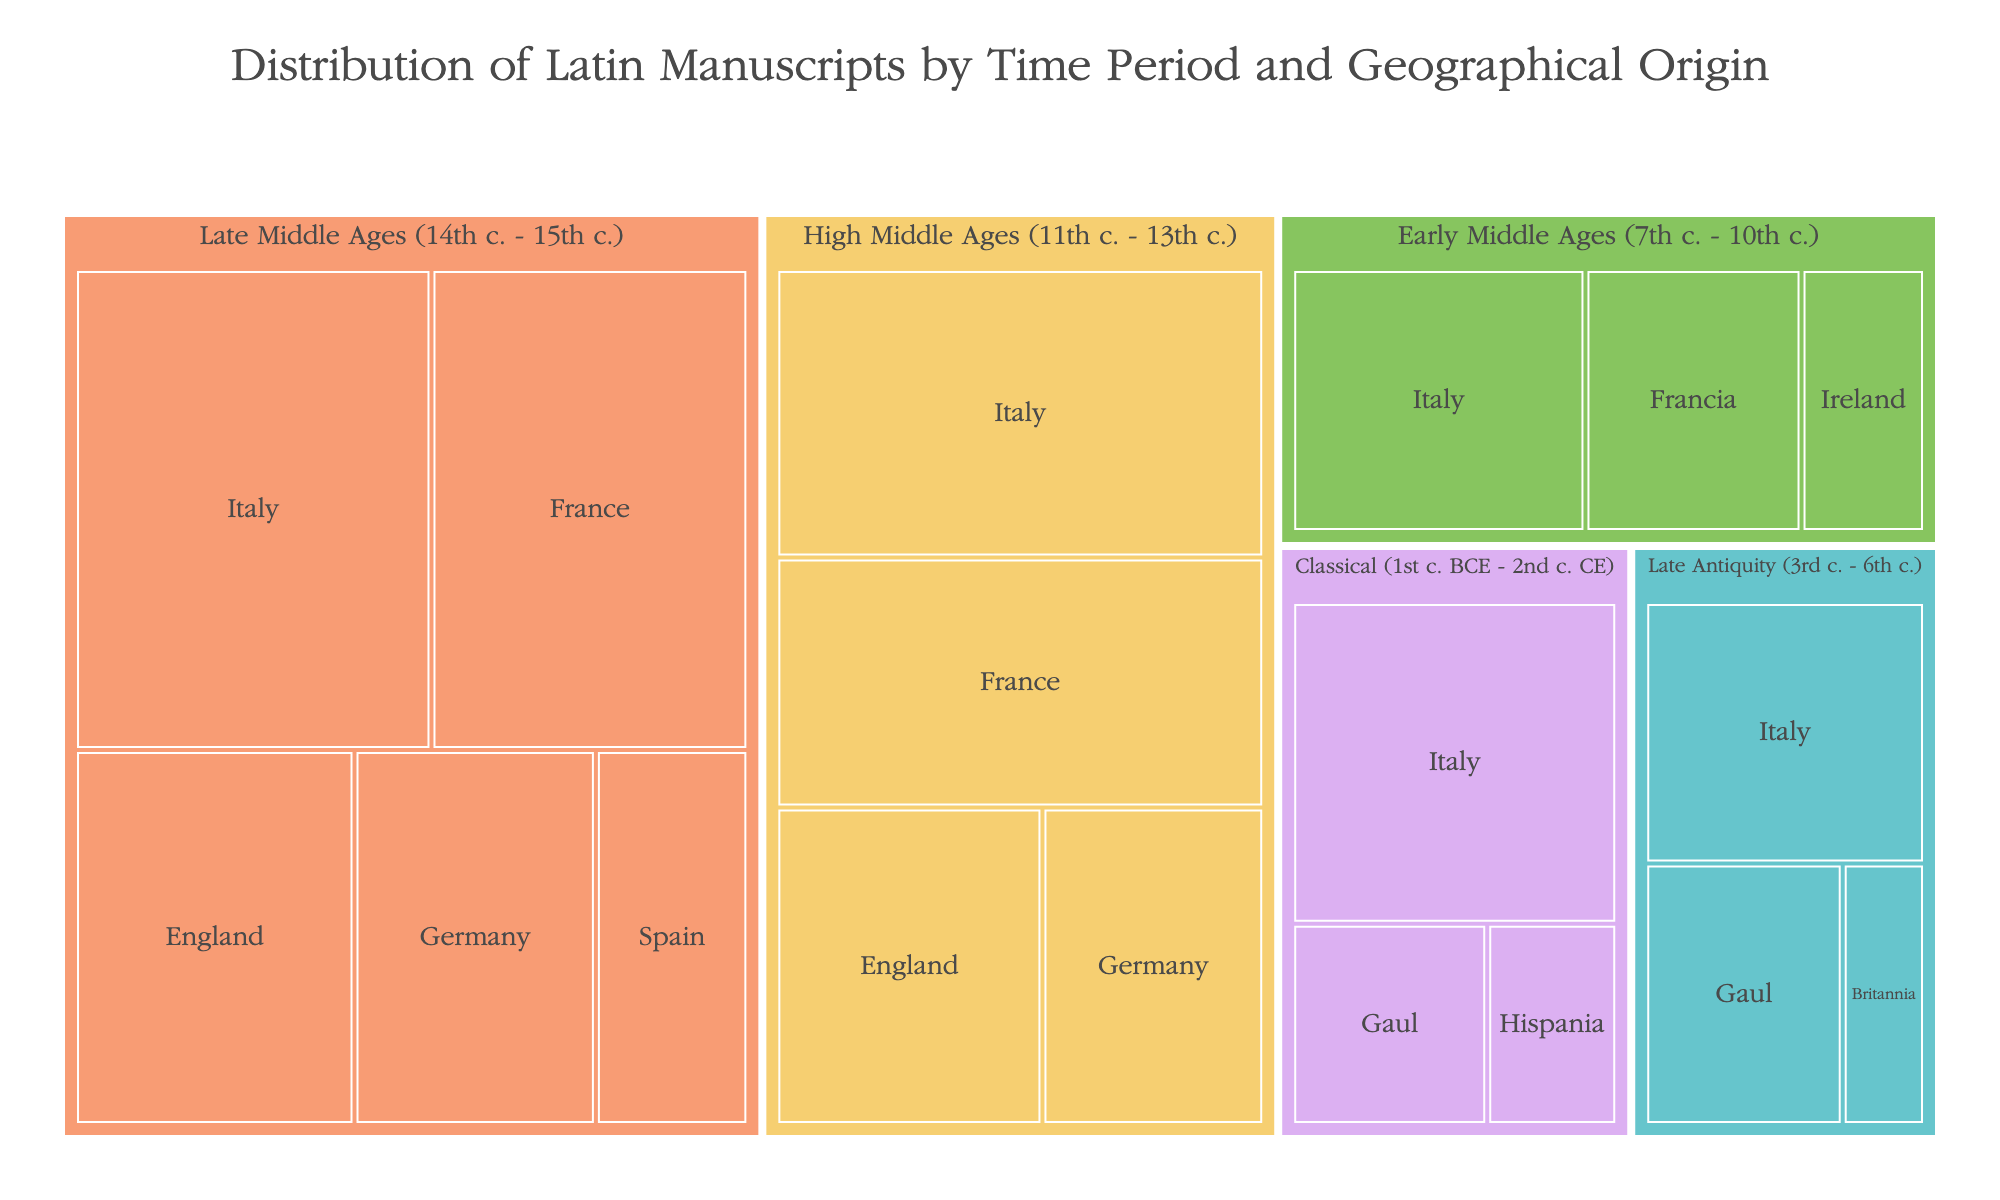What's the total number of manuscripts from the Classical period? To find the total number of manuscripts from the Classical period, we sum the manuscript counts for Italy, Gaul, and Hispania: 120 (Italy) + 45 (Gaul) + 30 (Hispania) = 195
Answer: 195 Which period has the highest number of manuscripts from Italy? By observing the figure, we can compare the manuscript counts from Italy across all periods. The Late Middle Ages period has 180 manuscripts from Italy, which is the highest.
Answer: Late Middle Ages How many more manuscripts are there from France in the High Middle Ages compared to the Early Middle Ages? France has 130 manuscripts in the High Middle Ages and 70 manuscripts in the Early Middle Ages. The difference is 130 - 70 = 60 manuscripts.
Answer: 60 Which region has the lowest number of manuscripts in Late Antiquity? In Late Antiquity, we compare the manuscript counts for each region: Italy (85), Gaul (60), Britannia (25). Britannia has the lowest number of manuscripts.
Answer: Britannia What is the combined manuscript count for regions in the Early Middle Ages? To find the total for the Early Middle Ages, sum the manuscripts from Italy (95), Francia (70), and Ireland (40): 95 + 70 + 40 = 205 manuscripts.
Answer: 205 Is the number of manuscripts from England in the Late Middle Ages greater than all the manuscripts from Hispania during the Classical period? England has 110 manuscripts in the Late Middle Ages, while Hispania has 30 manuscripts during the Classical period. Comparing the two, 110 is greater than 30.
Answer: Yes Which period and region combination has the maximum manuscript count? Observing the figure, Italy during the Late Middle Ages has the highest count with 180 manuscripts.
Answer: Italy in Late Middle Ages In which period does Germany appear as a region? By observing the labeled regions in each period, Germany appears in the High Middle Ages and Late Middle Ages.
Answer: High Middle Ages, Late Middle Ages How does the manuscript count of Italy in the Early Middle Ages compare to that of Late Antiquity? Italy has 95 manuscripts in the Early Middle Ages and 85 manuscripts in Late Antiquity. Early Middle Ages has 10 more manuscripts compared to Late Antiquity.
Answer: Higher What region has no manuscripts in the High Middle Ages according to the figure? By observing the regions listed in the High Middle Ages, Hispania does not appear, indicating no manuscripts from this region in that period.
Answer: Hispania 